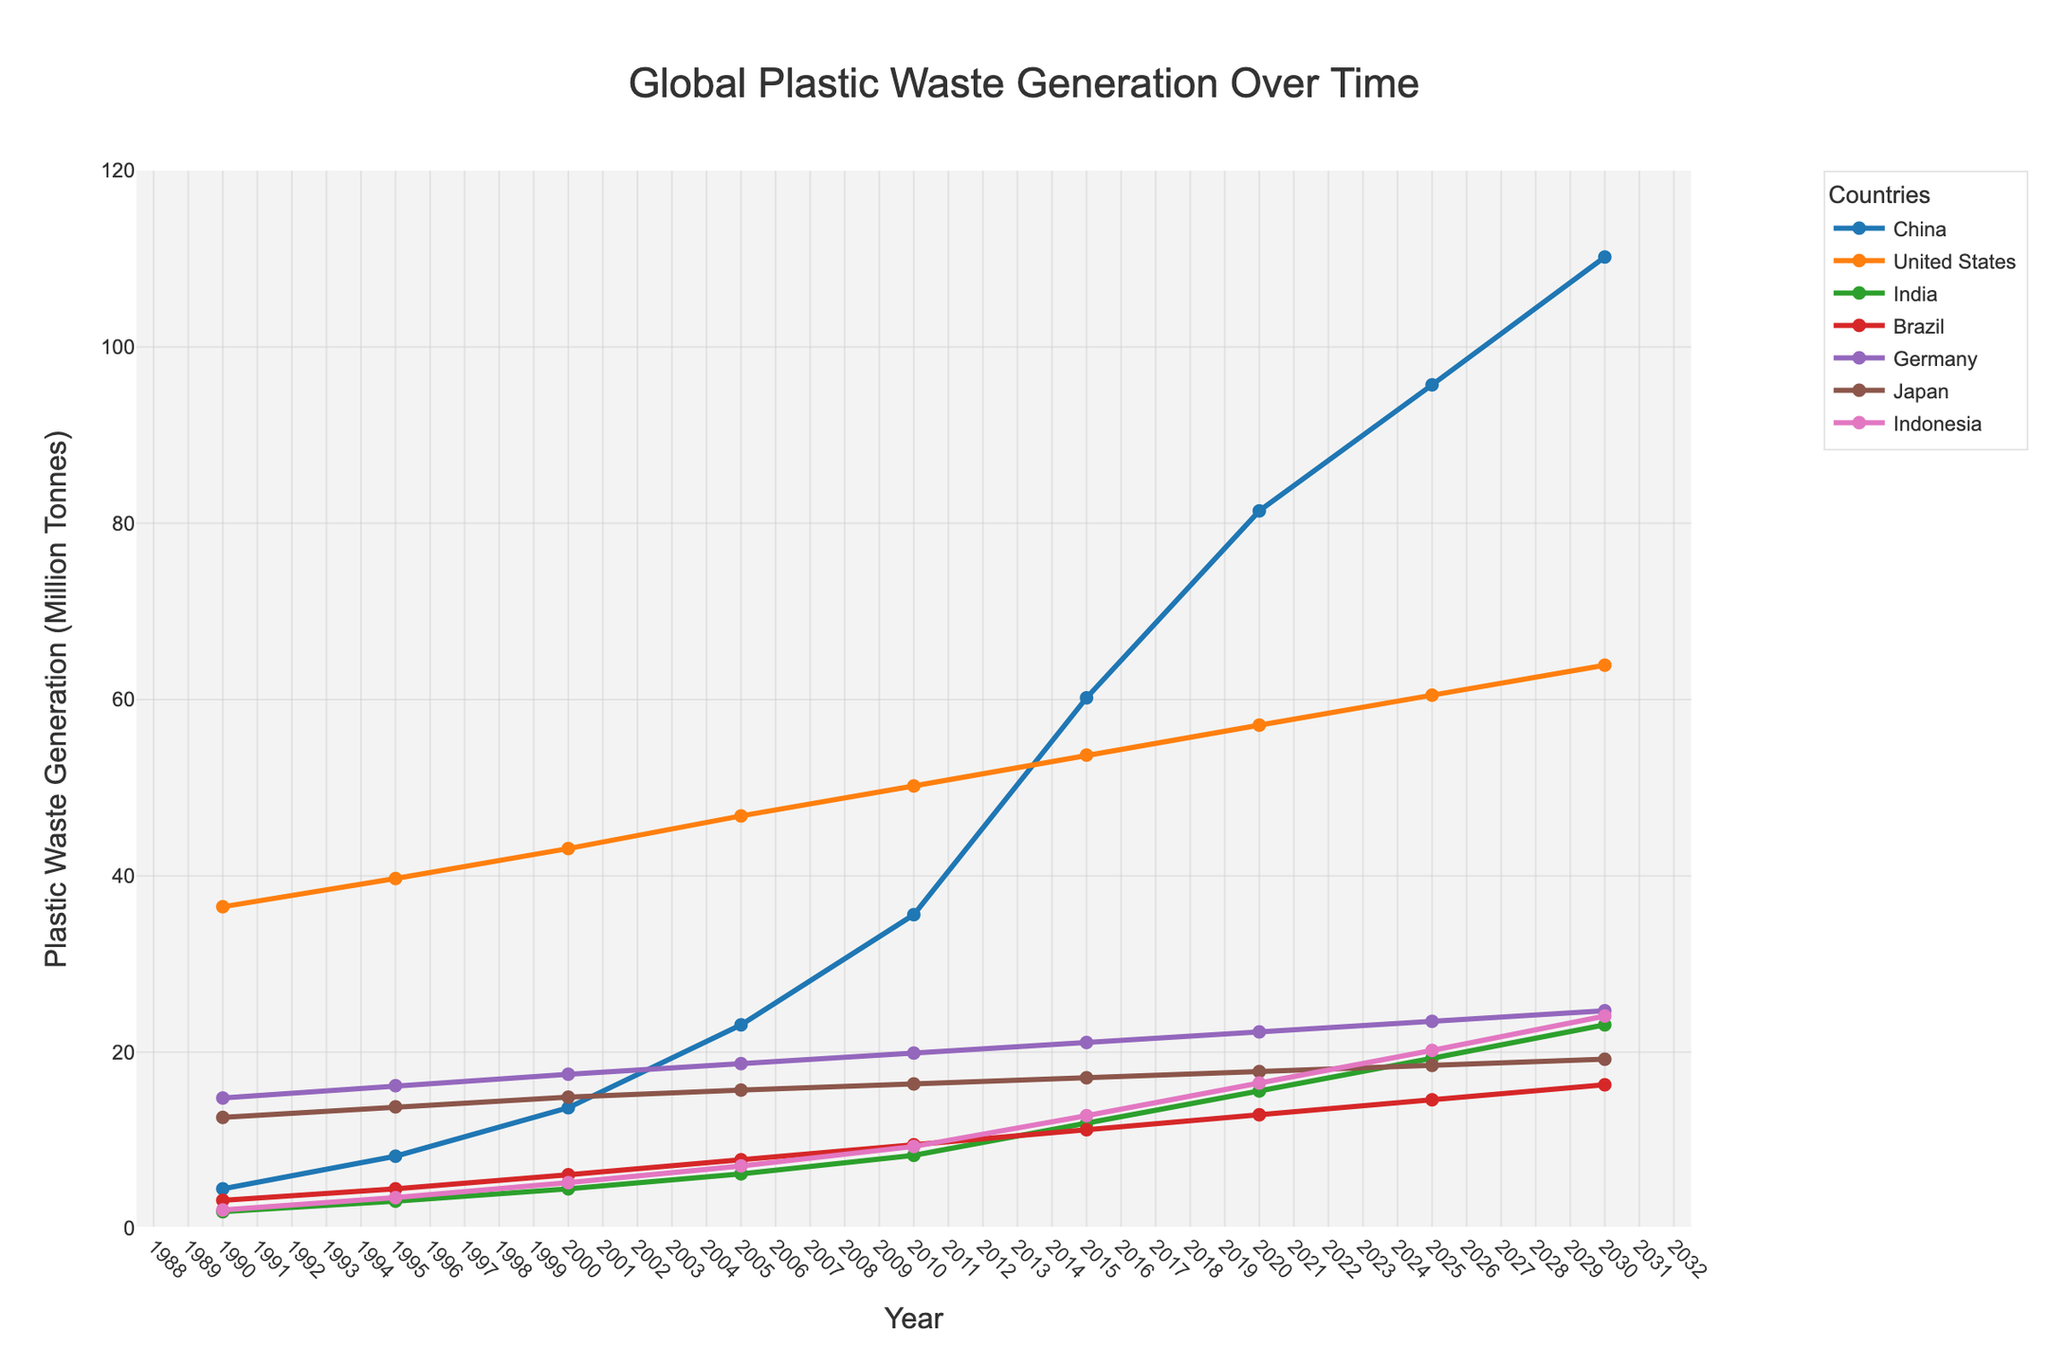What year did China surpass the United States in plastic waste generation? To determine this, look at the marked lines for China and the United States and identify the point where China's line surpasses the U.S. line. China's output surpasses the U.S. between 2015 and 2020.
Answer: 2020 Which country had the steepest increase in plastic waste generation between 1990 and 2020? Comparing the slopes of the lines for each country from 1990 to 2020 shows that China has the steepest increase.
Answer: China How much plastic waste did Germany generate in 1995 and 2015 combined? Identify Germany's values in 1995 and 2015 from the chart, which are 16.2 million tonnes and 21.1 million tonnes, respectively. Adding them yields 16.2 + 21.1 = 37.3 million tonnes.
Answer: 37.3 million tonnes In which year did Japan's plastic waste generation nearly stabilize, showing minimal growth? Observe Japan's line for phases where it becomes nearly horizontal, indicating stabilization. This occurs around 2005 to 2025.
Answer: 2005 to 2025 Compare the plastic waste generation of India and Brazil in 2010. Which country generates more, and by how much? Look at the 2010 values for India (8.3 million tonnes) and Brazil (9.5 million tonnes). The difference is 9.5 - 8.3 = 1.2 million tonnes. Brazil generates more.
Answer: Brazil by 1.2 million tonnes What is the average plastic waste generation across all countries in the year 2020? From the chart, sum the 2020 values for each country: 81.4 (China) + 57.1 (U.S.) + 15.6 (India) + 12.9 (Brazil) + 22.3 (Germany) + 17.8 (Japan) + 16.5 (Indonesia) = 223.6 million tonnes. Divide by 7 to get the average: 223.6 / 7 ≈ 31.94 million tonnes.
Answer: ~31.94 million tonnes Which country has the least plastic waste generation in the year 1990? Identify the country with the lowest line point in 1990, which is India at 1.9 million tonnes.
Answer: India Has there ever been a year where Brazil generated more plastic waste than Japan? Compare the lines for Brazil and Japan across all years and note that Japan always generates more plastic waste than Brazil.
Answer: No 